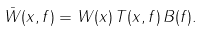<formula> <loc_0><loc_0><loc_500><loc_500>\bar { W } ( { x } , f ) = W ( { x } ) \, T ( { x } , f ) \, B ( f ) .</formula> 